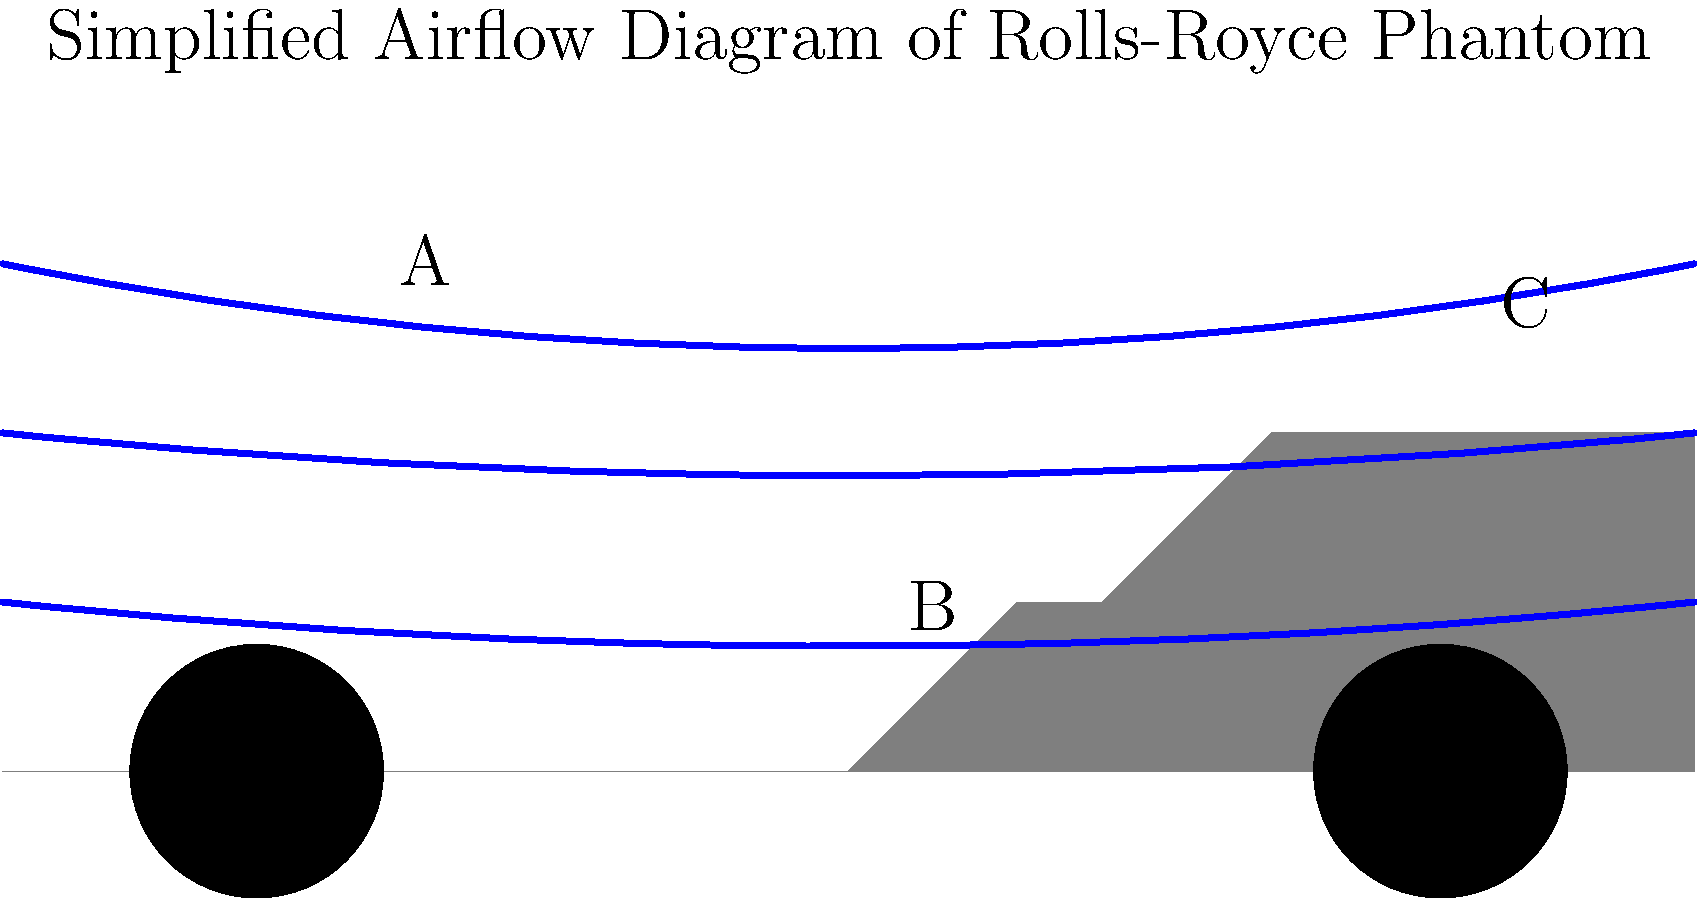Based on the simplified airflow diagram of the Rolls-Royce Phantom, which area is likely to experience the highest air pressure, and how does this affect the car's aerodynamics? To analyze the aerodynamics of the Rolls-Royce Phantom using the simplified diagram:

1. Observe the airflow lines:
   - The upper line represents the air flowing over the car's roof
   - The middle line shows air flowing around the windshield
   - The lower line indicates air moving under the car

2. Identify key areas:
   A: Front of the car (grille and bumper)
   B: Windshield and hood junction
   C: Rear of the car

3. Analyze air pressure:
   - Area A experiences the highest air pressure due to the car moving into stationary air
   - This creates a high-pressure zone, known as the stagnation point

4. Effect on aerodynamics:
   - High pressure at the front (A) pushes against the car's forward motion
   - This increases aerodynamic drag, reducing efficiency
   - The pressure difference between A and C creates lift, affecting stability

5. Rolls-Royce design considerations:
   - The Phantom's grille is designed to manage this high-pressure zone
   - Smooth transitions (e.g., at B) help reduce turbulence
   - The overall shape aims to balance luxury aesthetics with aerodynamic efficiency

The high pressure at the front (A) increases drag and affects the car's aerodynamic efficiency, which Rolls-Royce engineers must consider in the Phantom's design to maintain performance and luxury standards.
Answer: Area A (front), increasing drag and affecting efficiency 